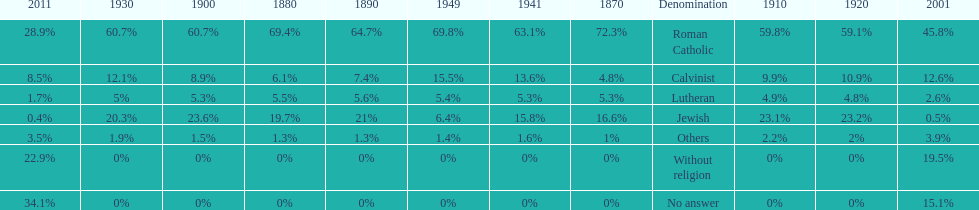Which denomination held the largest percentage in 1880? Roman Catholic. 